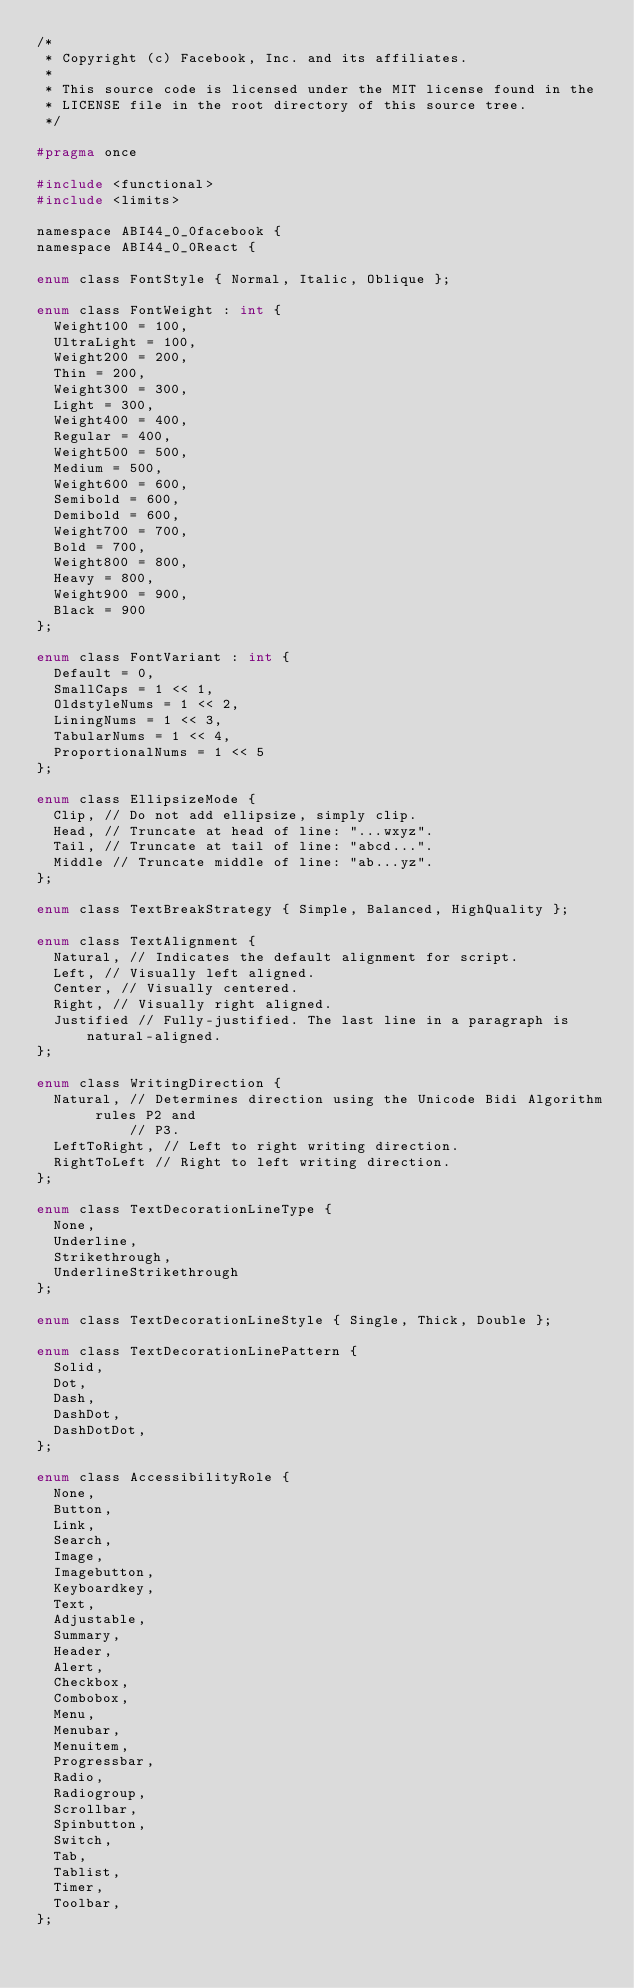Convert code to text. <code><loc_0><loc_0><loc_500><loc_500><_C_>/*
 * Copyright (c) Facebook, Inc. and its affiliates.
 *
 * This source code is licensed under the MIT license found in the
 * LICENSE file in the root directory of this source tree.
 */

#pragma once

#include <functional>
#include <limits>

namespace ABI44_0_0facebook {
namespace ABI44_0_0React {

enum class FontStyle { Normal, Italic, Oblique };

enum class FontWeight : int {
  Weight100 = 100,
  UltraLight = 100,
  Weight200 = 200,
  Thin = 200,
  Weight300 = 300,
  Light = 300,
  Weight400 = 400,
  Regular = 400,
  Weight500 = 500,
  Medium = 500,
  Weight600 = 600,
  Semibold = 600,
  Demibold = 600,
  Weight700 = 700,
  Bold = 700,
  Weight800 = 800,
  Heavy = 800,
  Weight900 = 900,
  Black = 900
};

enum class FontVariant : int {
  Default = 0,
  SmallCaps = 1 << 1,
  OldstyleNums = 1 << 2,
  LiningNums = 1 << 3,
  TabularNums = 1 << 4,
  ProportionalNums = 1 << 5
};

enum class EllipsizeMode {
  Clip, // Do not add ellipsize, simply clip.
  Head, // Truncate at head of line: "...wxyz".
  Tail, // Truncate at tail of line: "abcd...".
  Middle // Truncate middle of line: "ab...yz".
};

enum class TextBreakStrategy { Simple, Balanced, HighQuality };

enum class TextAlignment {
  Natural, // Indicates the default alignment for script.
  Left, // Visually left aligned.
  Center, // Visually centered.
  Right, // Visually right aligned.
  Justified // Fully-justified. The last line in a paragraph is natural-aligned.
};

enum class WritingDirection {
  Natural, // Determines direction using the Unicode Bidi Algorithm rules P2 and
           // P3.
  LeftToRight, // Left to right writing direction.
  RightToLeft // Right to left writing direction.
};

enum class TextDecorationLineType {
  None,
  Underline,
  Strikethrough,
  UnderlineStrikethrough
};

enum class TextDecorationLineStyle { Single, Thick, Double };

enum class TextDecorationLinePattern {
  Solid,
  Dot,
  Dash,
  DashDot,
  DashDotDot,
};

enum class AccessibilityRole {
  None,
  Button,
  Link,
  Search,
  Image,
  Imagebutton,
  Keyboardkey,
  Text,
  Adjustable,
  Summary,
  Header,
  Alert,
  Checkbox,
  Combobox,
  Menu,
  Menubar,
  Menuitem,
  Progressbar,
  Radio,
  Radiogroup,
  Scrollbar,
  Spinbutton,
  Switch,
  Tab,
  Tablist,
  Timer,
  Toolbar,
};
</code> 